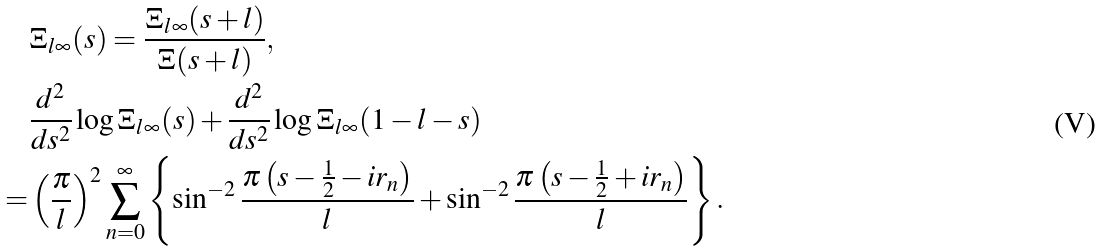Convert formula to latex. <formula><loc_0><loc_0><loc_500><loc_500>& \Xi _ { l \infty } ( s ) = \frac { \Xi _ { l \infty } ( s + l ) } { \Xi ( s + l ) } , \\ & \frac { d ^ { 2 } } { d s ^ { 2 } } \log \Xi _ { l \infty } ( s ) + \frac { d ^ { 2 } } { d s ^ { 2 } } \log \Xi _ { l \infty } ( 1 - l - s ) \\ = & \left ( \frac { \pi } { l } \right ) ^ { 2 } \sum _ { n = 0 } ^ { \infty } \left \{ \sin ^ { - 2 } \frac { \pi \left ( s - \frac { 1 } { 2 } - i r _ { n } \right ) } { l } + \sin ^ { - 2 } \frac { \pi \left ( s - \frac { 1 } { 2 } + i r _ { n } \right ) } { l } \right \} .</formula> 